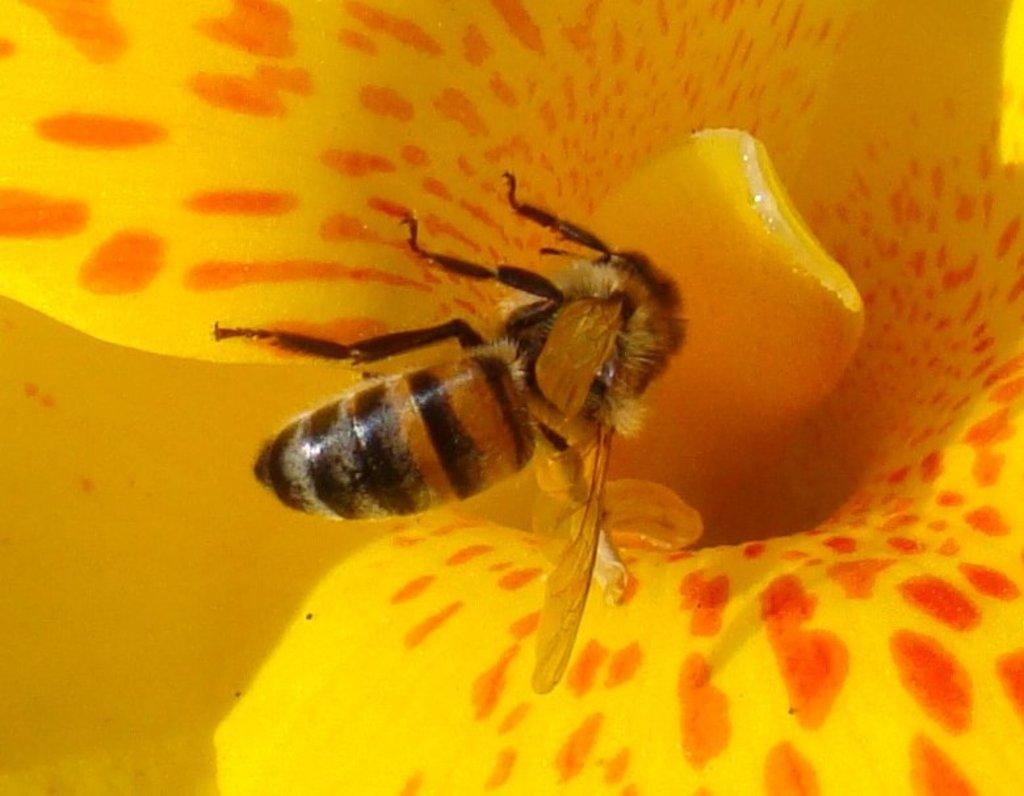What type of insect is in the image? There is a honey bee in the image. Where is the honey bee located? The honey bee is on a flower. What type of notebook is the rat holding in the image? There is no rat or notebook present in the image; it only features a honey bee on a flower. 